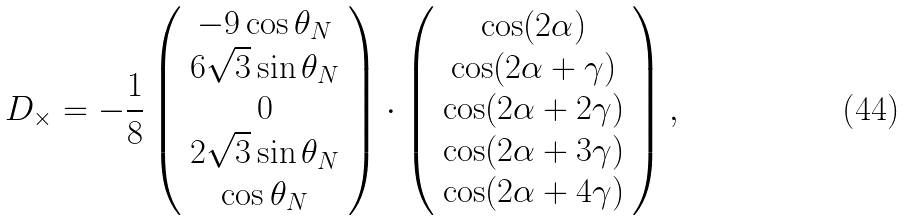<formula> <loc_0><loc_0><loc_500><loc_500>D _ { \times } = - \frac { 1 } { 8 } \left ( \begin{array} { c } - 9 \cos \theta _ { N } \\ 6 \sqrt { 3 } \sin \theta _ { N } \\ 0 \\ 2 \sqrt { 3 } \sin \theta _ { N } \\ \cos \theta _ { N } \end{array} \right ) \cdot \left ( \begin{array} { c } \cos ( 2 \alpha ) \\ \cos ( 2 \alpha + \gamma ) \\ \cos ( 2 \alpha + 2 \gamma ) \\ \cos ( 2 \alpha + 3 \gamma ) \\ \cos ( 2 \alpha + 4 \gamma ) \end{array} \right ) ,</formula> 